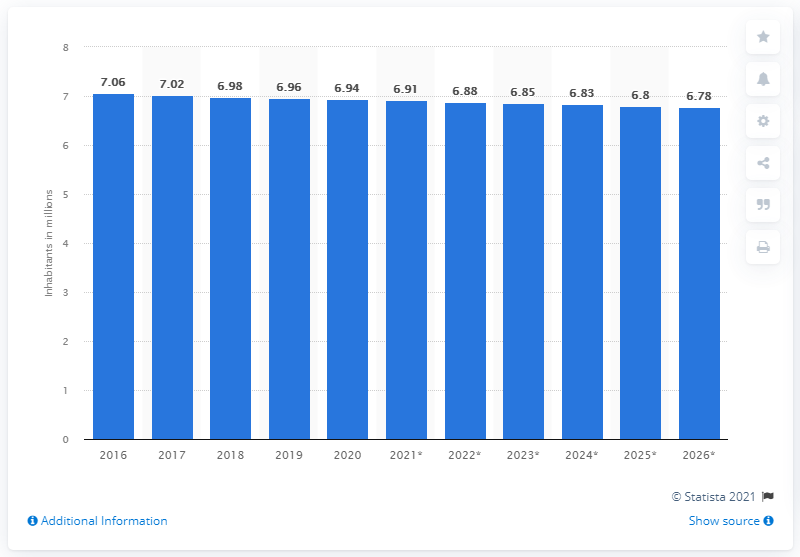Outline some significant characteristics in this image. In 2020, the population of Serbia was 6.88 million. In 2020, the population of Serbia came to an end. 